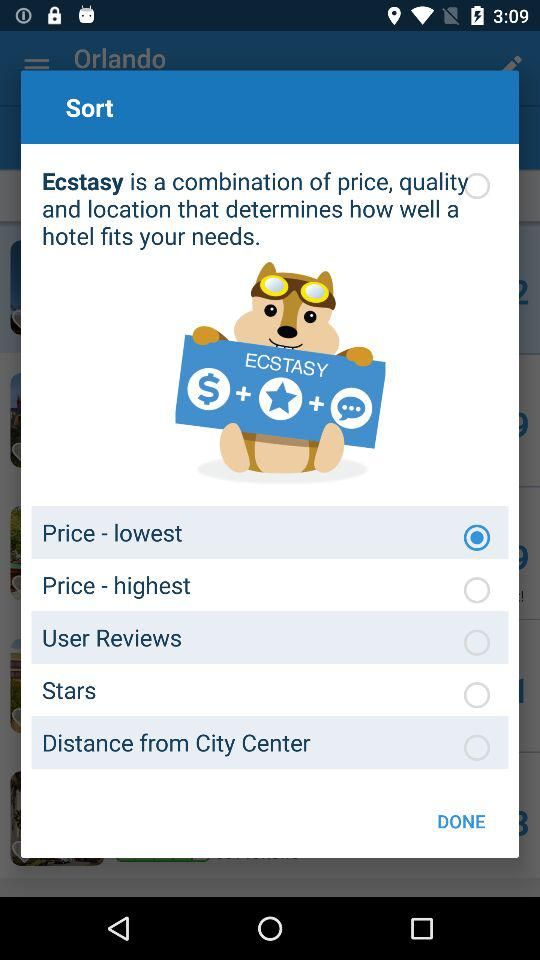What sorting option is selected? The option is "Price - lowest". 